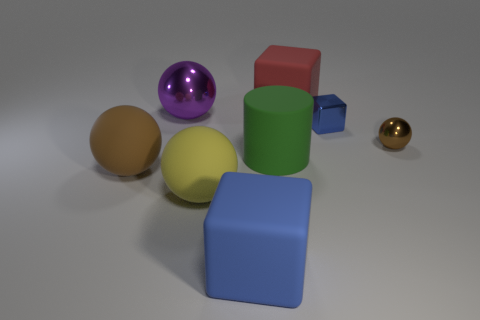Are there more large brown rubber balls to the right of the blue metallic thing than big brown objects that are in front of the large yellow rubber thing?
Keep it short and to the point. No. What number of big red things have the same shape as the large blue thing?
Keep it short and to the point. 1. There is a red object that is the same size as the brown rubber thing; what is its material?
Give a very brief answer. Rubber. Are there any big brown spheres made of the same material as the large yellow thing?
Offer a terse response. Yes. Are there fewer rubber cubes behind the large green cylinder than matte blocks?
Your answer should be very brief. Yes. What material is the big block that is in front of the large matte block behind the brown matte thing?
Give a very brief answer. Rubber. What is the shape of the metallic thing that is right of the green matte cylinder and behind the small brown object?
Keep it short and to the point. Cube. What number of other things are the same color as the matte cylinder?
Offer a terse response. 0. What number of objects are either matte objects in front of the small brown metallic thing or tiny metallic blocks?
Ensure brevity in your answer.  5. There is a large rubber cylinder; is it the same color as the large matte cube that is behind the big yellow rubber ball?
Give a very brief answer. No. 